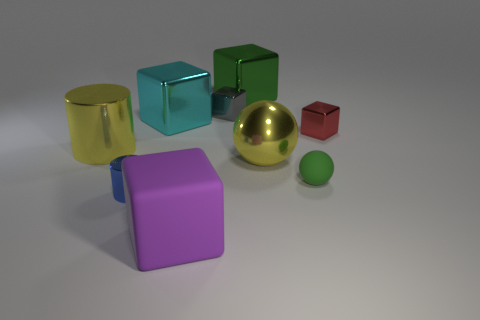How many tiny objects are both in front of the tiny matte ball and to the right of the tiny green thing?
Offer a terse response. 0. Is the yellow thing that is to the left of the large matte cube made of the same material as the small cylinder?
Your answer should be compact. Yes. What is the shape of the green thing in front of the object left of the cylinder that is in front of the large yellow shiny cylinder?
Your answer should be very brief. Sphere. Are there an equal number of small green things behind the tiny sphere and large green metallic blocks that are to the right of the red metallic block?
Make the answer very short. Yes. What color is the metal sphere that is the same size as the purple cube?
Your response must be concise. Yellow. How many big things are blue metal cylinders or yellow metal cylinders?
Give a very brief answer. 1. What is the big object that is both on the left side of the purple thing and in front of the red shiny thing made of?
Provide a succinct answer. Metal. There is a tiny shiny object that is to the left of the big purple thing; is it the same shape as the shiny thing that is on the right side of the yellow shiny sphere?
Give a very brief answer. No. There is a thing that is the same color as the large shiny ball; what is its shape?
Provide a succinct answer. Cylinder. How many objects are small metal objects in front of the matte sphere or tiny blue balls?
Keep it short and to the point. 1. 